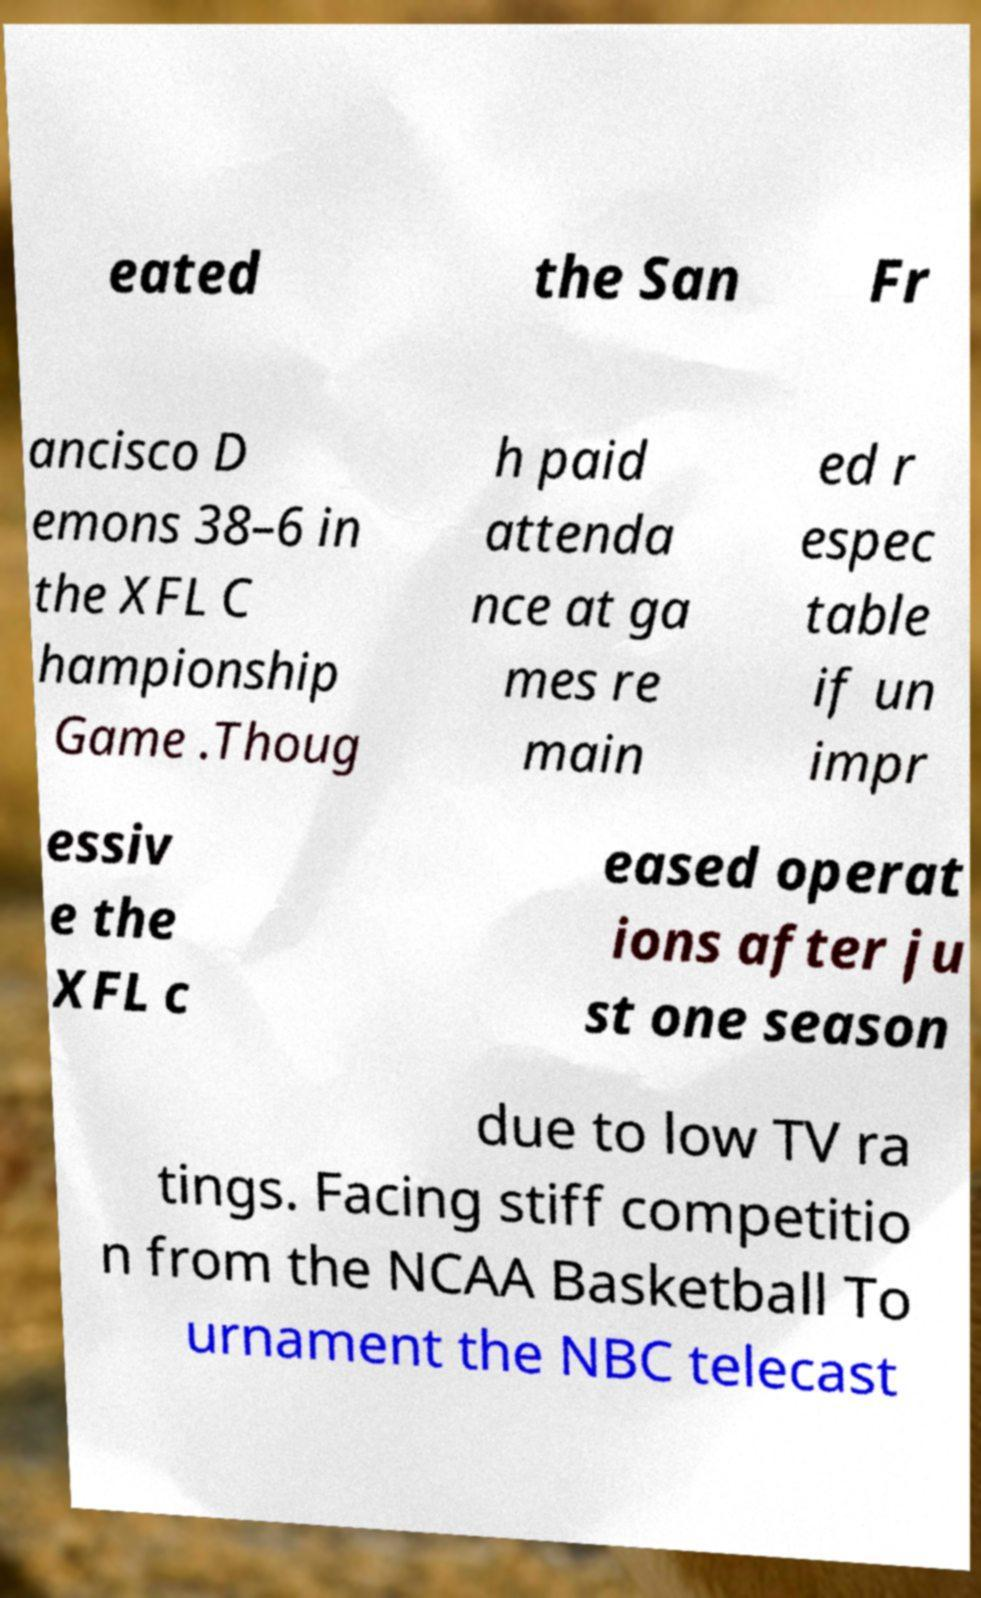There's text embedded in this image that I need extracted. Can you transcribe it verbatim? eated the San Fr ancisco D emons 38–6 in the XFL C hampionship Game .Thoug h paid attenda nce at ga mes re main ed r espec table if un impr essiv e the XFL c eased operat ions after ju st one season due to low TV ra tings. Facing stiff competitio n from the NCAA Basketball To urnament the NBC telecast 